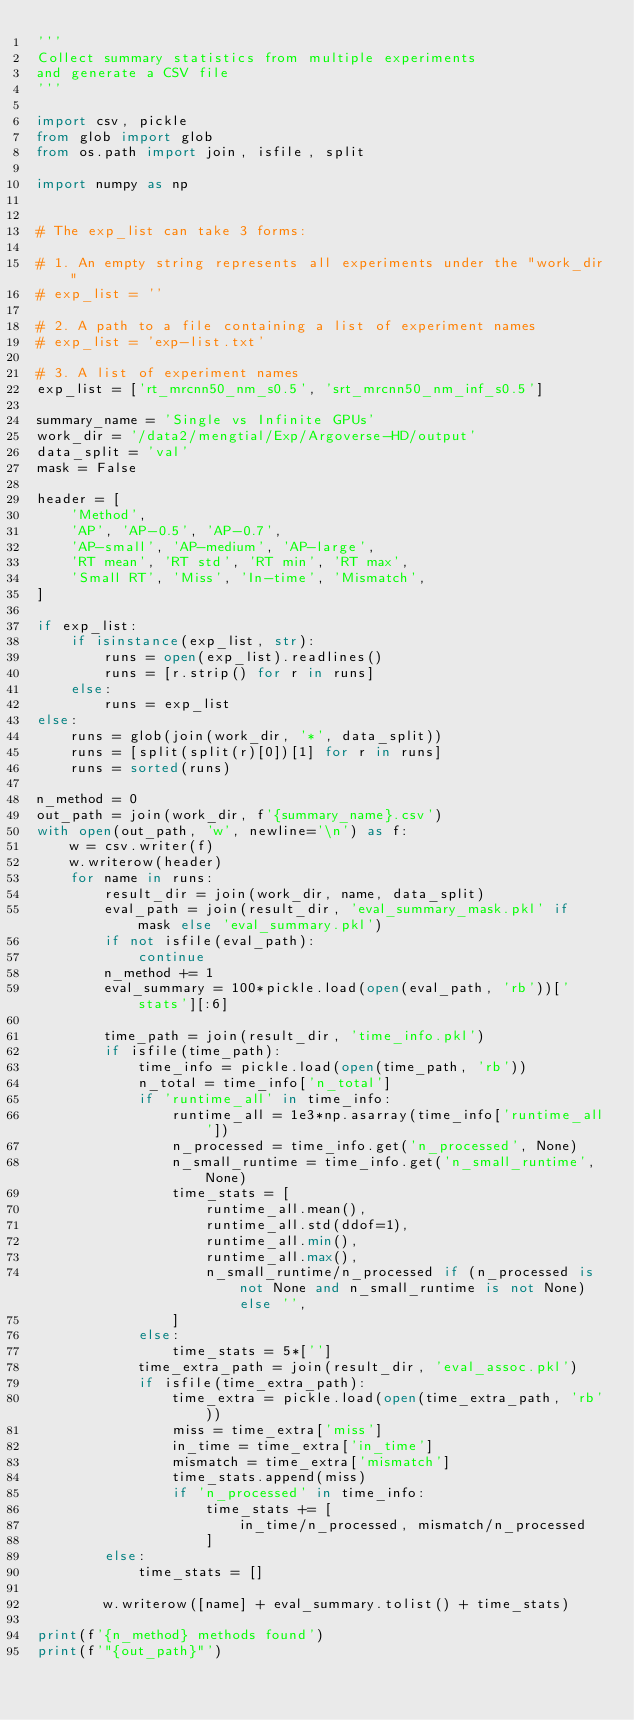<code> <loc_0><loc_0><loc_500><loc_500><_Python_>'''
Collect summary statistics from multiple experiments
and generate a CSV file
'''

import csv, pickle
from glob import glob
from os.path import join, isfile, split

import numpy as np


# The exp_list can take 3 forms:

# 1. An empty string represents all experiments under the "work_dir"
# exp_list = ''

# 2. A path to a file containing a list of experiment names
# exp_list = 'exp-list.txt'

# 3. A list of experiment names
exp_list = ['rt_mrcnn50_nm_s0.5', 'srt_mrcnn50_nm_inf_s0.5']

summary_name = 'Single vs Infinite GPUs'
work_dir = '/data2/mengtial/Exp/Argoverse-HD/output'
data_split = 'val'
mask = False

header = [
    'Method',
    'AP', 'AP-0.5', 'AP-0.7',
    'AP-small', 'AP-medium', 'AP-large',
    'RT mean', 'RT std', 'RT min', 'RT max',
    'Small RT', 'Miss', 'In-time', 'Mismatch',
]

if exp_list:
    if isinstance(exp_list, str):
        runs = open(exp_list).readlines()
        runs = [r.strip() for r in runs]
    else:
        runs = exp_list
else:
    runs = glob(join(work_dir, '*', data_split))
    runs = [split(split(r)[0])[1] for r in runs]
    runs = sorted(runs)

n_method = 0
out_path = join(work_dir, f'{summary_name}.csv')
with open(out_path, 'w', newline='\n') as f:
    w = csv.writer(f)
    w.writerow(header)
    for name in runs:
        result_dir = join(work_dir, name, data_split)
        eval_path = join(result_dir, 'eval_summary_mask.pkl' if mask else 'eval_summary.pkl')
        if not isfile(eval_path):
            continue
        n_method += 1
        eval_summary = 100*pickle.load(open(eval_path, 'rb'))['stats'][:6]

        time_path = join(result_dir, 'time_info.pkl')
        if isfile(time_path):
            time_info = pickle.load(open(time_path, 'rb'))
            n_total = time_info['n_total']
            if 'runtime_all' in time_info:
                runtime_all = 1e3*np.asarray(time_info['runtime_all'])
                n_processed = time_info.get('n_processed', None)
                n_small_runtime = time_info.get('n_small_runtime', None)
                time_stats = [
                    runtime_all.mean(),
                    runtime_all.std(ddof=1),
                    runtime_all.min(),
                    runtime_all.max(),
                    n_small_runtime/n_processed if (n_processed is not None and n_small_runtime is not None) else '',
                ]
            else:
                time_stats = 5*['']
            time_extra_path = join(result_dir, 'eval_assoc.pkl')
            if isfile(time_extra_path):
                time_extra = pickle.load(open(time_extra_path, 'rb'))
                miss = time_extra['miss']
                in_time = time_extra['in_time']
                mismatch = time_extra['mismatch']
                time_stats.append(miss)
                if 'n_processed' in time_info:
                    time_stats += [
                        in_time/n_processed, mismatch/n_processed
                    ]
        else:
            time_stats = []

        w.writerow([name] + eval_summary.tolist() + time_stats)

print(f'{n_method} methods found')
print(f'"{out_path}"')
</code> 